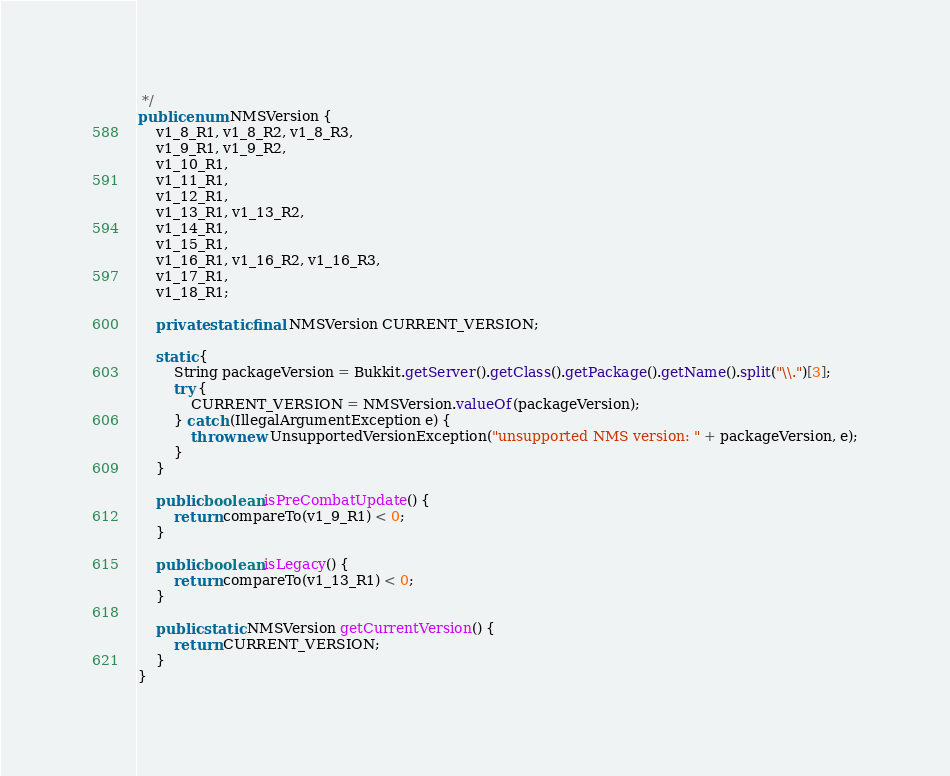<code> <loc_0><loc_0><loc_500><loc_500><_Java_> */
public enum NMSVersion {
    v1_8_R1, v1_8_R2, v1_8_R3,
    v1_9_R1, v1_9_R2,
    v1_10_R1,
    v1_11_R1,
    v1_12_R1,
    v1_13_R1, v1_13_R2,
    v1_14_R1,
    v1_15_R1,
    v1_16_R1, v1_16_R2, v1_16_R3,
    v1_17_R1,
    v1_18_R1;

    private static final NMSVersion CURRENT_VERSION;

    static {
        String packageVersion = Bukkit.getServer().getClass().getPackage().getName().split("\\.")[3];
        try {
            CURRENT_VERSION = NMSVersion.valueOf(packageVersion);
        } catch (IllegalArgumentException e) {
            throw new UnsupportedVersionException("unsupported NMS version: " + packageVersion, e);
        }
    }

    public boolean isPreCombatUpdate() {
        return compareTo(v1_9_R1) < 0;
    }

    public boolean isLegacy() {
        return compareTo(v1_13_R1) < 0;
    }

    public static NMSVersion getCurrentVersion() {
        return CURRENT_VERSION;
    }
}
</code> 